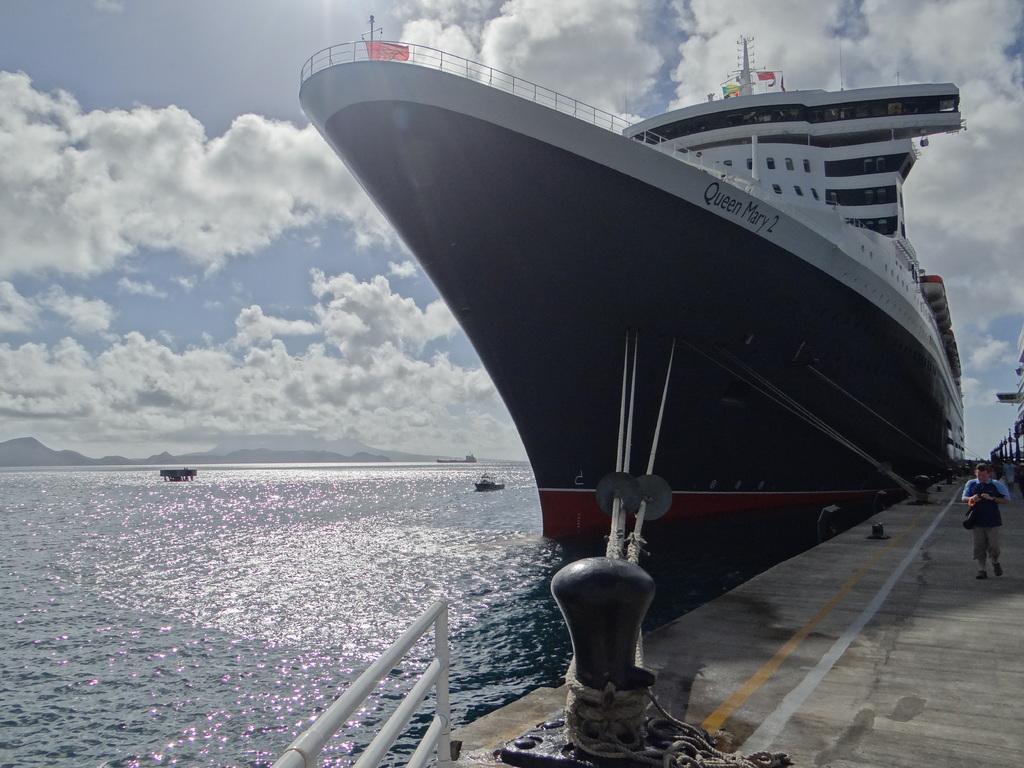Describe this image in one or two sentences. This is the picture of a sea. On the right side of the image there is a person walking. There is a ship and there is a rope tied to the rod and there is a hand rail. On the left side of the image there are boats on the water. At the back there are mountains. At the top there is sky and there are clouds. 